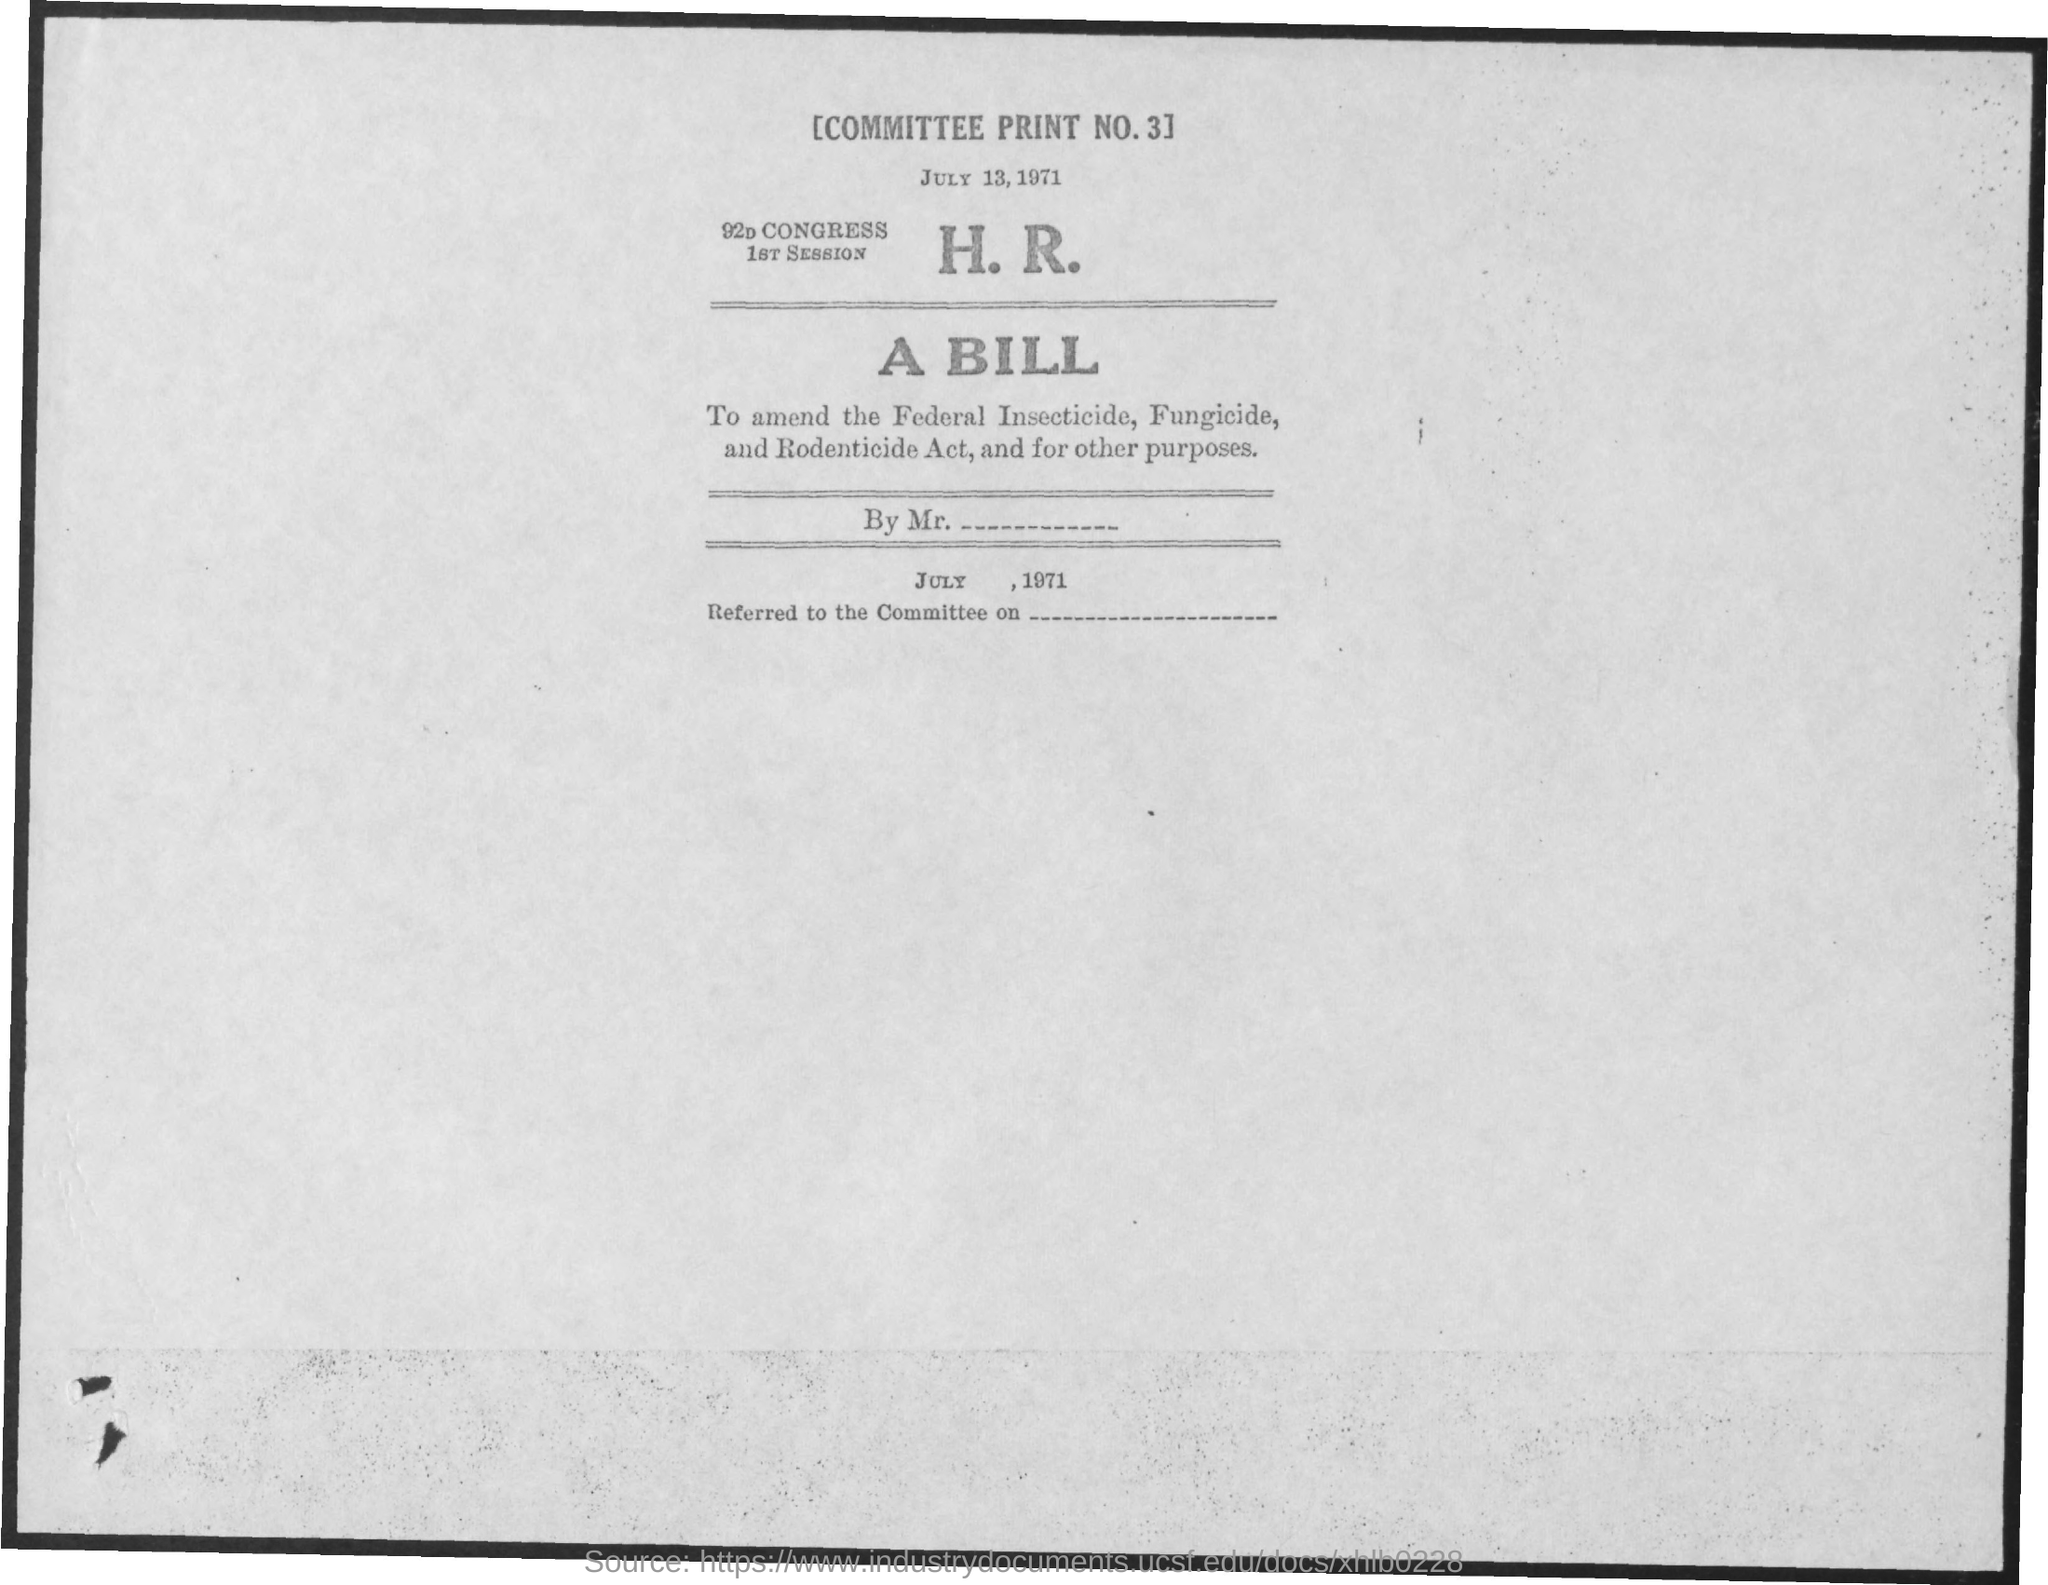What is the committee print no.?
Offer a very short reply. 3. When is the document dated?
Make the answer very short. JULY 13, 1971. 